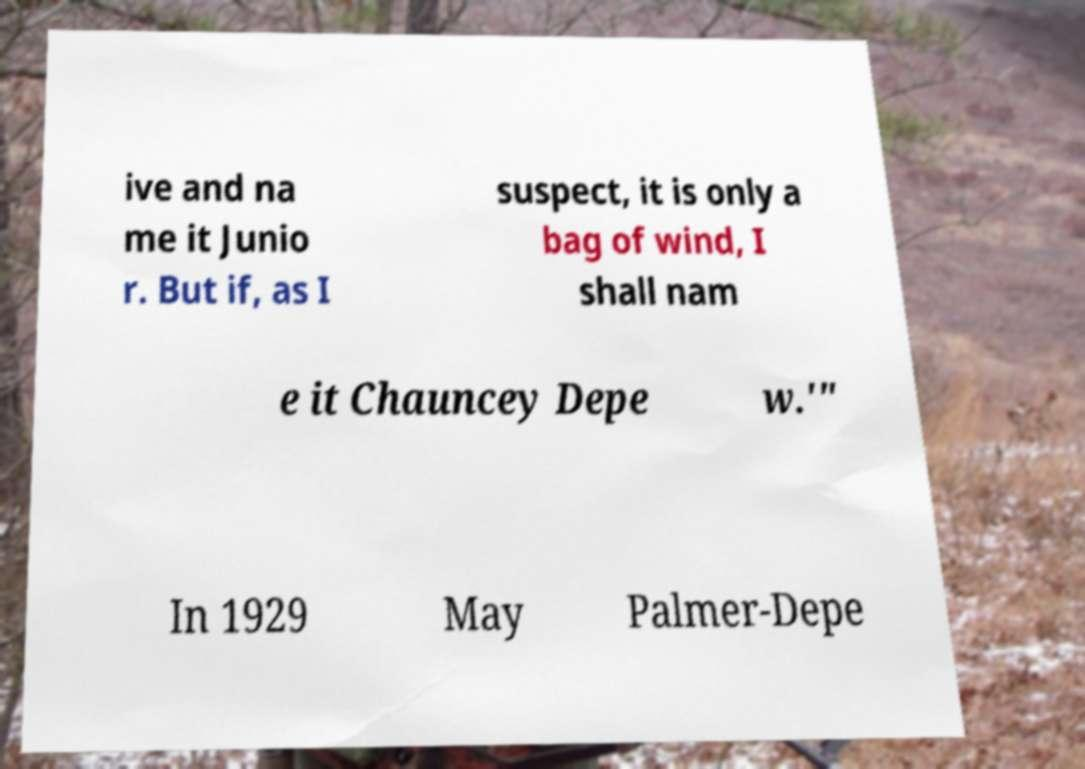For documentation purposes, I need the text within this image transcribed. Could you provide that? ive and na me it Junio r. But if, as I suspect, it is only a bag of wind, I shall nam e it Chauncey Depe w.'" In 1929 May Palmer-Depe 